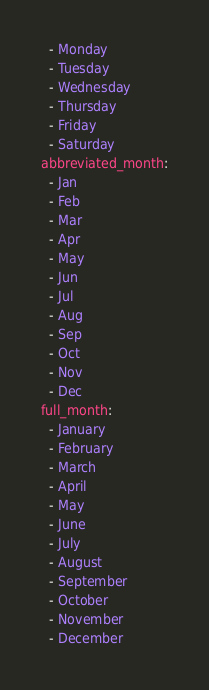<code> <loc_0><loc_0><loc_500><loc_500><_YAML_>  - Monday
  - Tuesday
  - Wednesday
  - Thursday
  - Friday
  - Saturday
abbreviated_month:
  - Jan
  - Feb
  - Mar
  - Apr
  - May
  - Jun
  - Jul
  - Aug
  - Sep
  - Oct
  - Nov
  - Dec
full_month:
  - January
  - February
  - March
  - April
  - May
  - June
  - July
  - August
  - September
  - October
  - November
  - December
</code> 